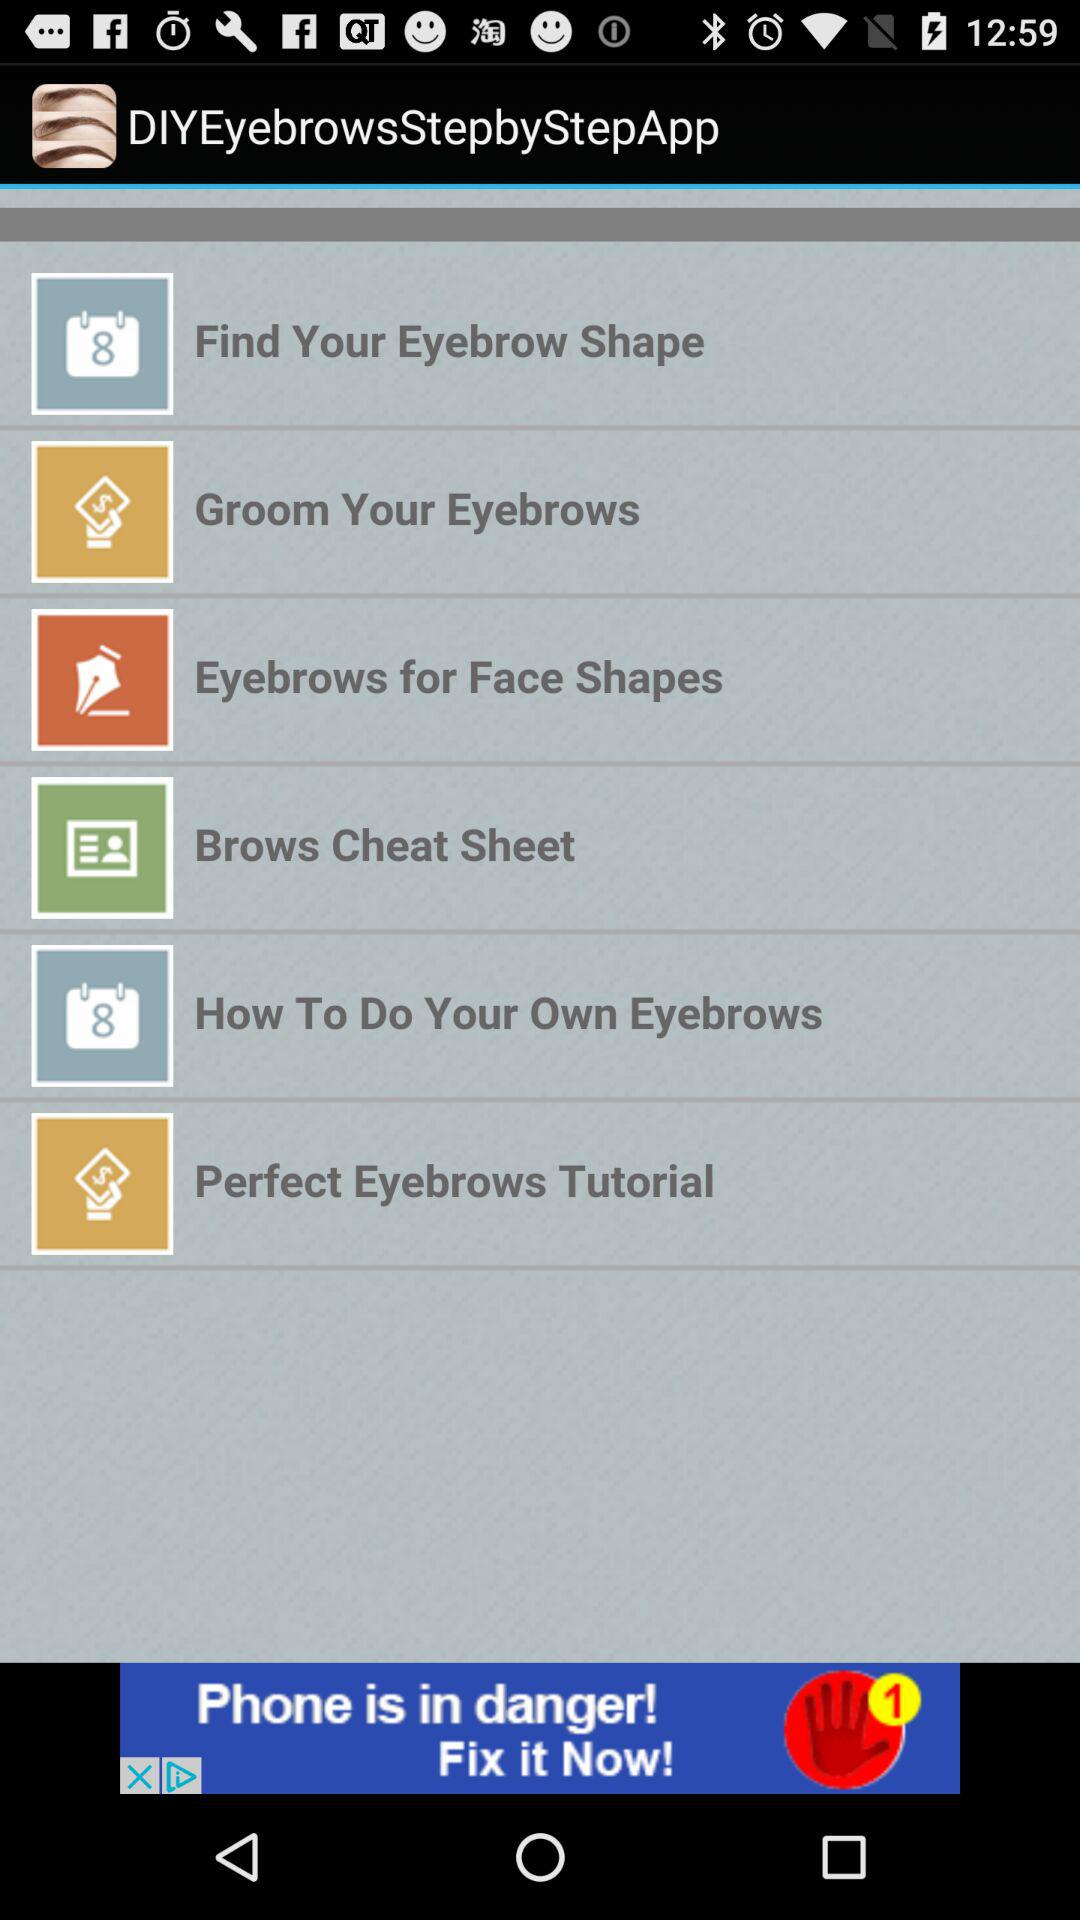What is the name of the application? The name of the application is "DIY Eyebrows Step by Step". 